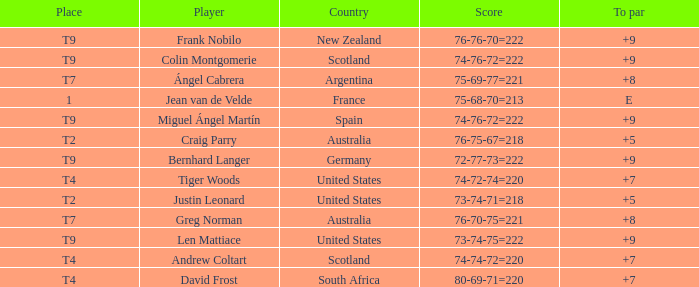What is the place number for the player with a To Par score of 'E'? 1.0. 